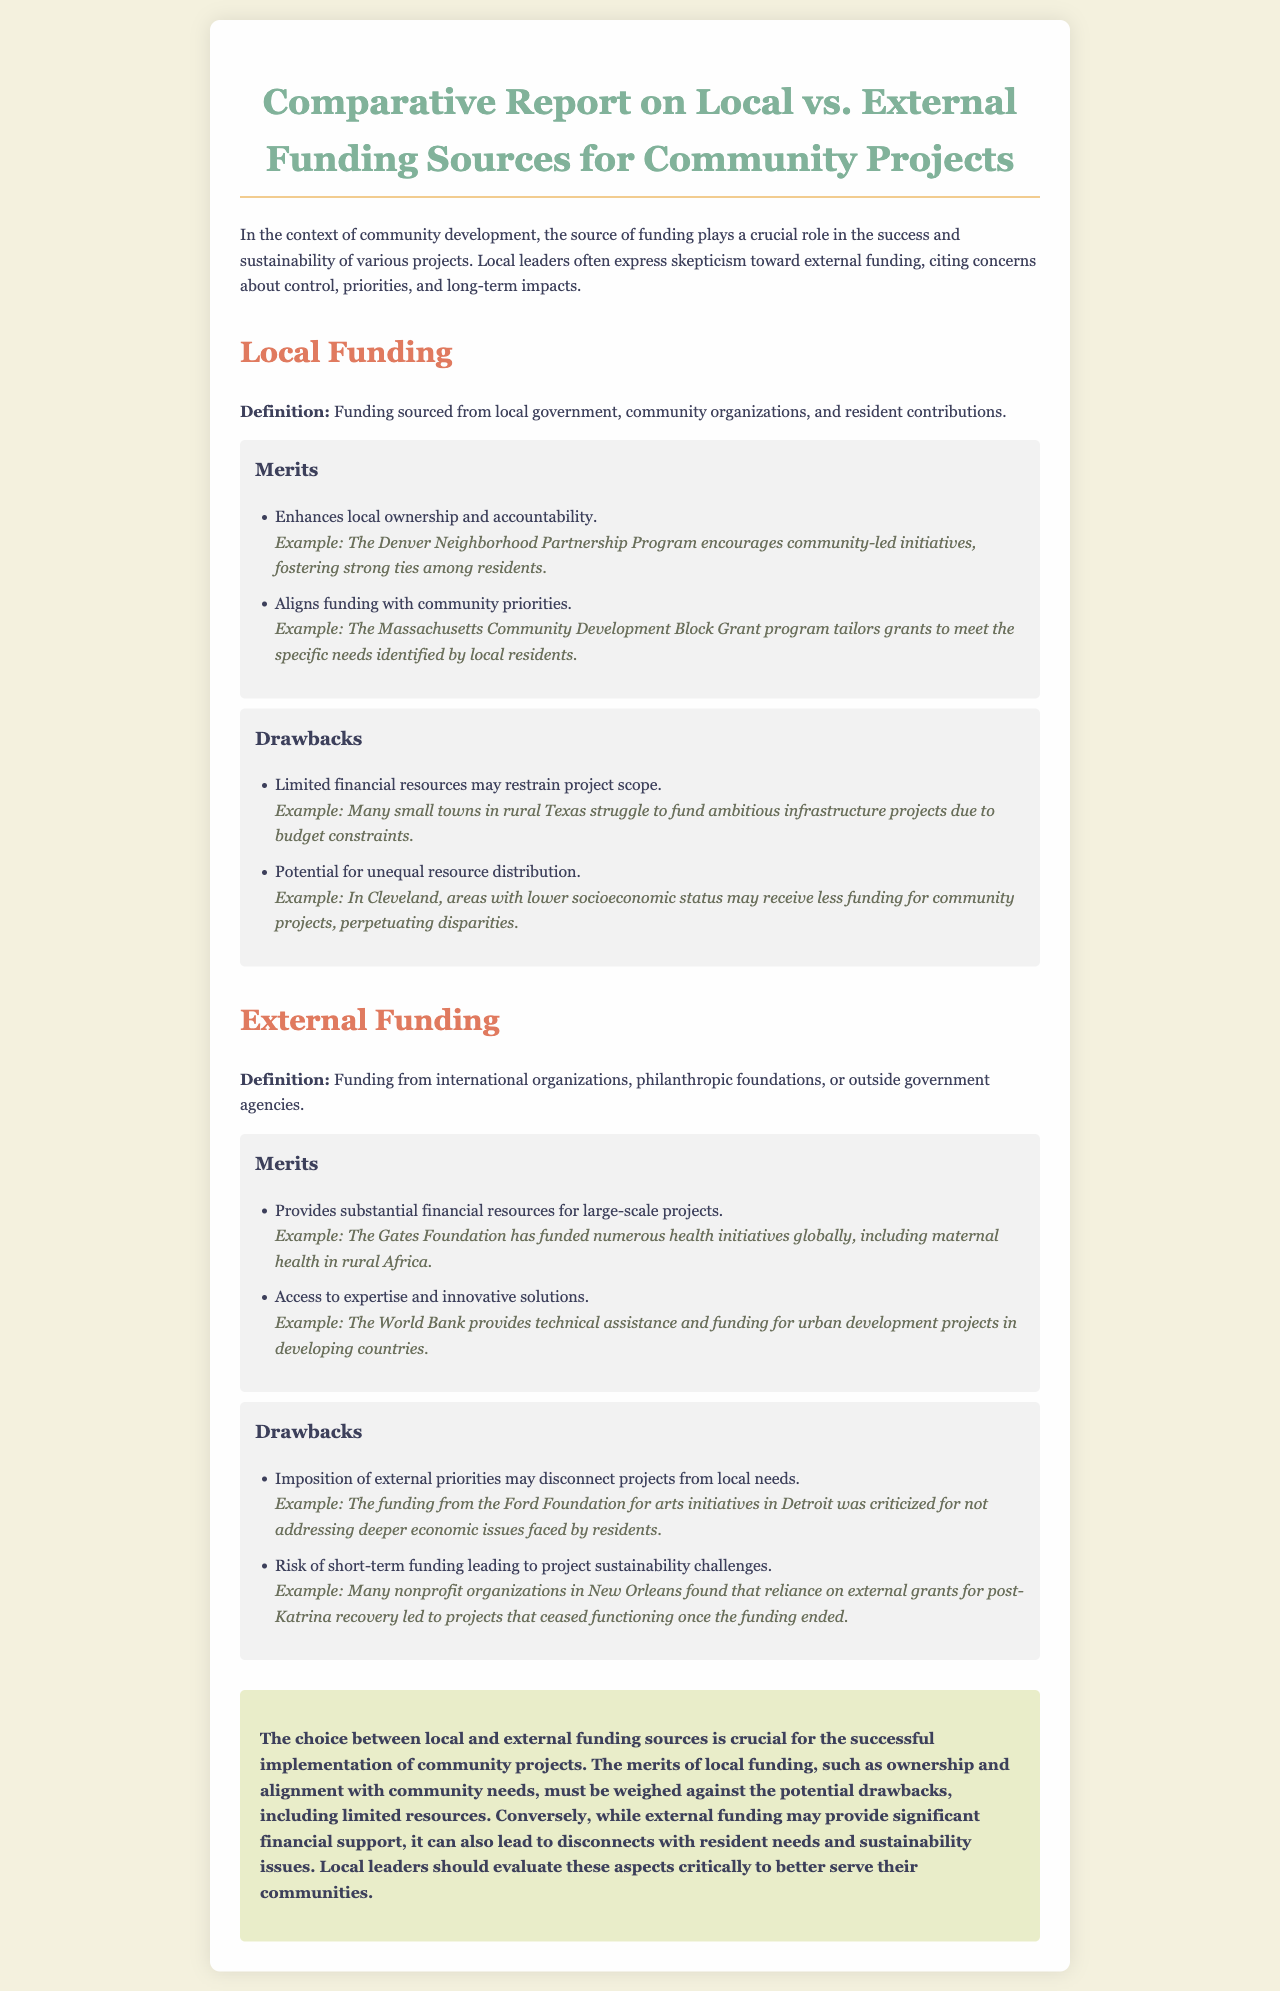What is the definition of local funding? Local funding is defined in the document as funding sourced from local government, community organizations, and resident contributions.
Answer: Funding sourced from local government, community organizations, and resident contributions What is one merit of local funding? One of the merits listed for local funding is enhancing local ownership and accountability.
Answer: Enhances local ownership and accountability What is a drawback associated with external funding? One of the drawbacks identified for external funding is the imposition of external priorities which may disconnect projects from local needs.
Answer: Imposition of external priorities may disconnect projects from local needs Who has provided substantial financial resources for large-scale projects? The Gates Foundation is mentioned in the document as having funded numerous health initiatives globally.
Answer: The Gates Foundation What is a reason local leaders might prefer local funding? Local leaders may prefer local funding because it aligns funding with community priorities.
Answer: Aligns funding with community priorities What type of document is this report classified as? The document is classified as a comparative report on local versus external funding sources for community projects.
Answer: Comparative report What issue arose from reliance on external grants post-Katrina? The reliance on external grants led to projects that ceased functioning once the funding ended.
Answer: Projects that ceased functioning once the funding ended Which community development program is mentioned as encouraging community-led initiatives? The Denver Neighborhood Partnership Program is cited as an example of a program that encourages community-led initiatives.
Answer: The Denver Neighborhood Partnership Program 